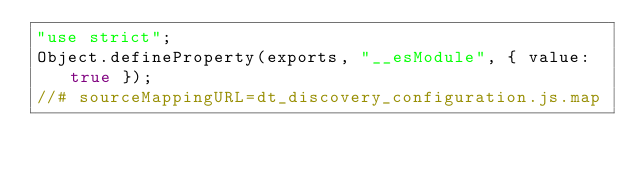<code> <loc_0><loc_0><loc_500><loc_500><_JavaScript_>"use strict";
Object.defineProperty(exports, "__esModule", { value: true });
//# sourceMappingURL=dt_discovery_configuration.js.map</code> 